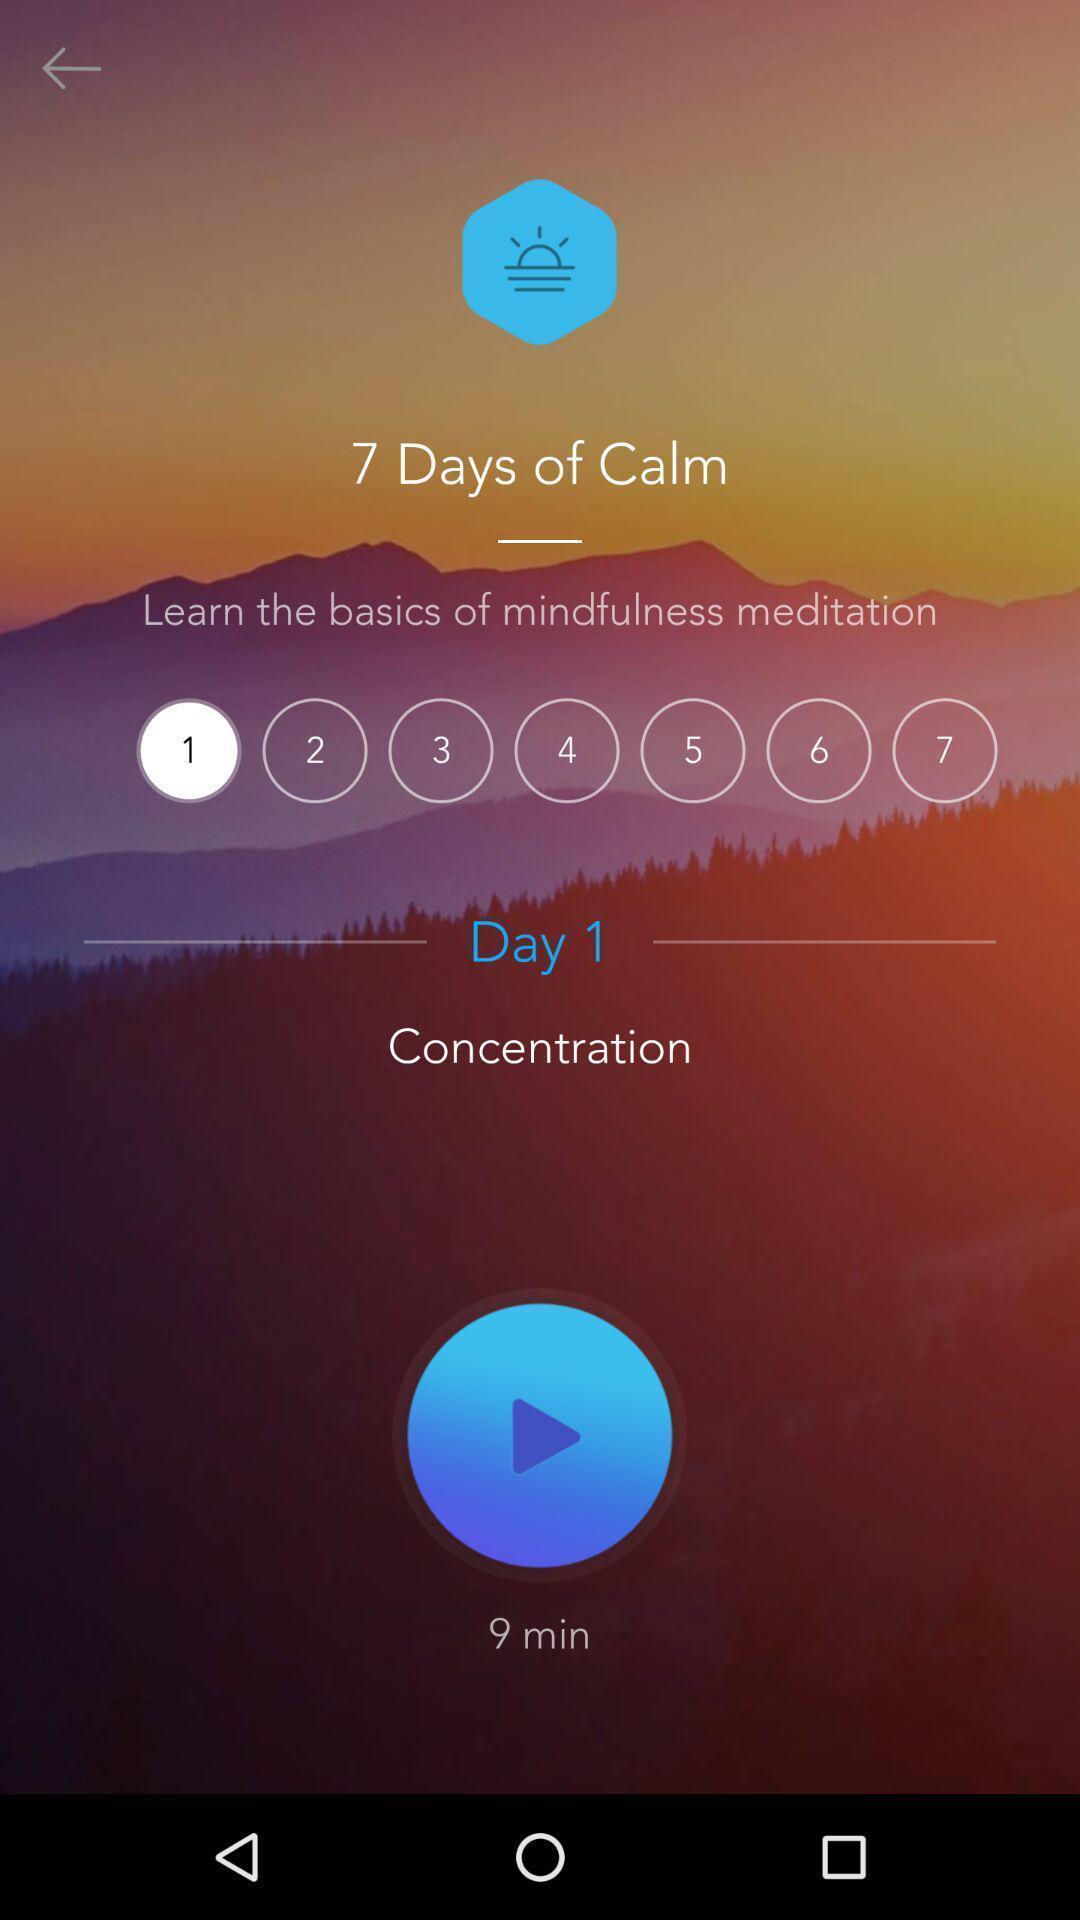Tell me what you see in this picture. Page shows the basics of meditation app. 